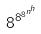<formula> <loc_0><loc_0><loc_500><loc_500>8 ^ { 8 ^ { 8 ^ { n ^ { h } } } }</formula> 